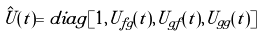<formula> <loc_0><loc_0><loc_500><loc_500>\hat { U } ( t ) = d i a g [ 1 , U _ { f g } ( t ) , U _ { g f } ( t ) , U _ { g g } ( t ) ]</formula> 